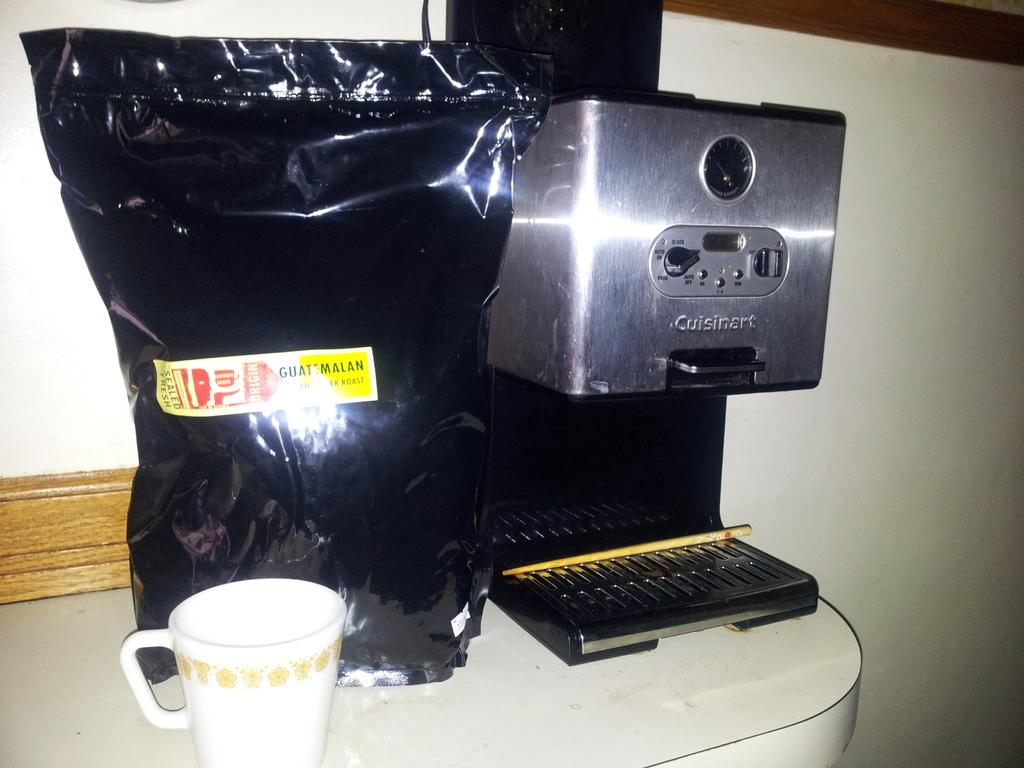Provide a one-sentence caption for the provided image. A bag of Guatamalan coffee sitting next to a coffee maker. 